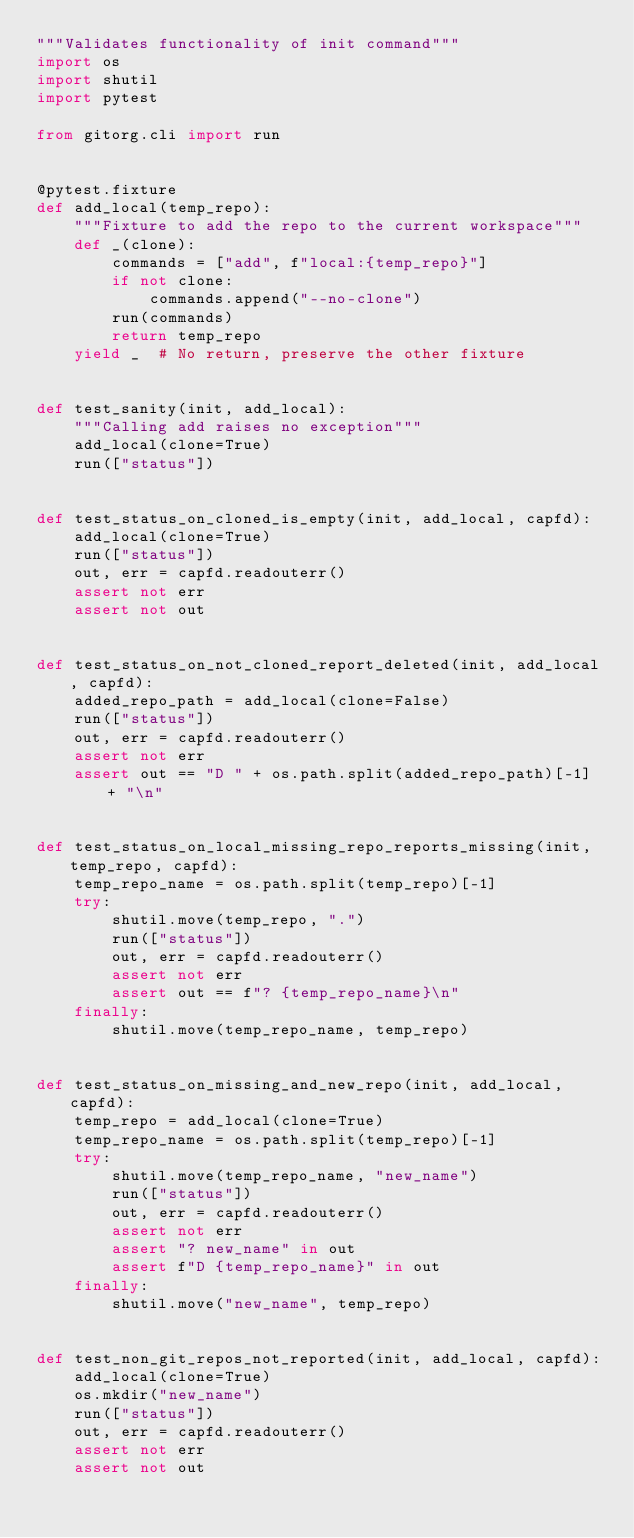<code> <loc_0><loc_0><loc_500><loc_500><_Python_>"""Validates functionality of init command"""
import os
import shutil
import pytest

from gitorg.cli import run


@pytest.fixture
def add_local(temp_repo):
    """Fixture to add the repo to the current workspace"""
    def _(clone):
        commands = ["add", f"local:{temp_repo}"]
        if not clone:
            commands.append("--no-clone")
        run(commands)
        return temp_repo
    yield _  # No return, preserve the other fixture


def test_sanity(init, add_local):
    """Calling add raises no exception"""
    add_local(clone=True)
    run(["status"])


def test_status_on_cloned_is_empty(init, add_local, capfd):
    add_local(clone=True)
    run(["status"])
    out, err = capfd.readouterr()
    assert not err
    assert not out


def test_status_on_not_cloned_report_deleted(init, add_local, capfd):
    added_repo_path = add_local(clone=False)
    run(["status"])
    out, err = capfd.readouterr()
    assert not err
    assert out == "D " + os.path.split(added_repo_path)[-1] + "\n"


def test_status_on_local_missing_repo_reports_missing(init, temp_repo, capfd):
    temp_repo_name = os.path.split(temp_repo)[-1]
    try:
        shutil.move(temp_repo, ".")
        run(["status"])
        out, err = capfd.readouterr()
        assert not err
        assert out == f"? {temp_repo_name}\n"
    finally:
        shutil.move(temp_repo_name, temp_repo)


def test_status_on_missing_and_new_repo(init, add_local, capfd):
    temp_repo = add_local(clone=True)
    temp_repo_name = os.path.split(temp_repo)[-1]
    try:
        shutil.move(temp_repo_name, "new_name")
        run(["status"])
        out, err = capfd.readouterr()
        assert not err
        assert "? new_name" in out
        assert f"D {temp_repo_name}" in out
    finally:
        shutil.move("new_name", temp_repo)


def test_non_git_repos_not_reported(init, add_local, capfd):
    add_local(clone=True)
    os.mkdir("new_name")
    run(["status"])
    out, err = capfd.readouterr()
    assert not err
    assert not out

</code> 